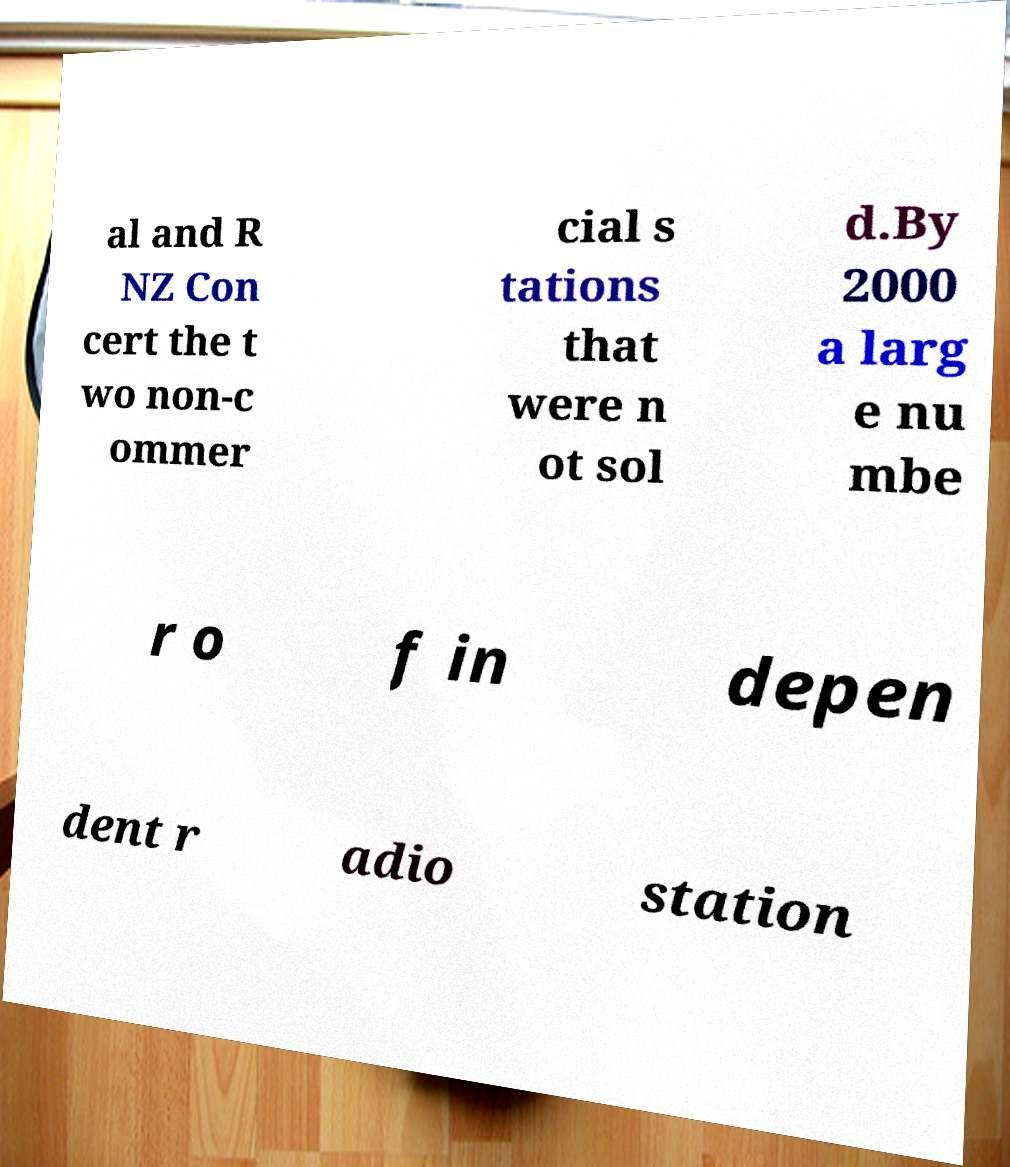Could you extract and type out the text from this image? al and R NZ Con cert the t wo non-c ommer cial s tations that were n ot sol d.By 2000 a larg e nu mbe r o f in depen dent r adio station 